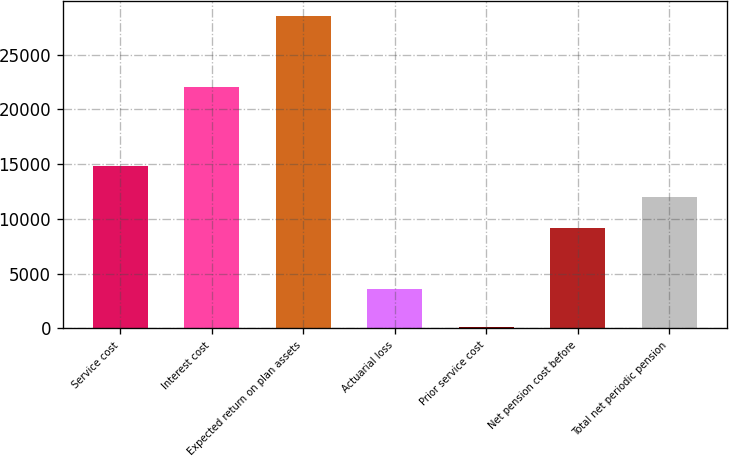Convert chart to OTSL. <chart><loc_0><loc_0><loc_500><loc_500><bar_chart><fcel>Service cost<fcel>Interest cost<fcel>Expected return on plan assets<fcel>Actuarial loss<fcel>Prior service cost<fcel>Net pension cost before<fcel>Total net periodic pension<nl><fcel>14806.4<fcel>22041<fcel>28495<fcel>3608<fcel>103<fcel>9128<fcel>11967.2<nl></chart> 